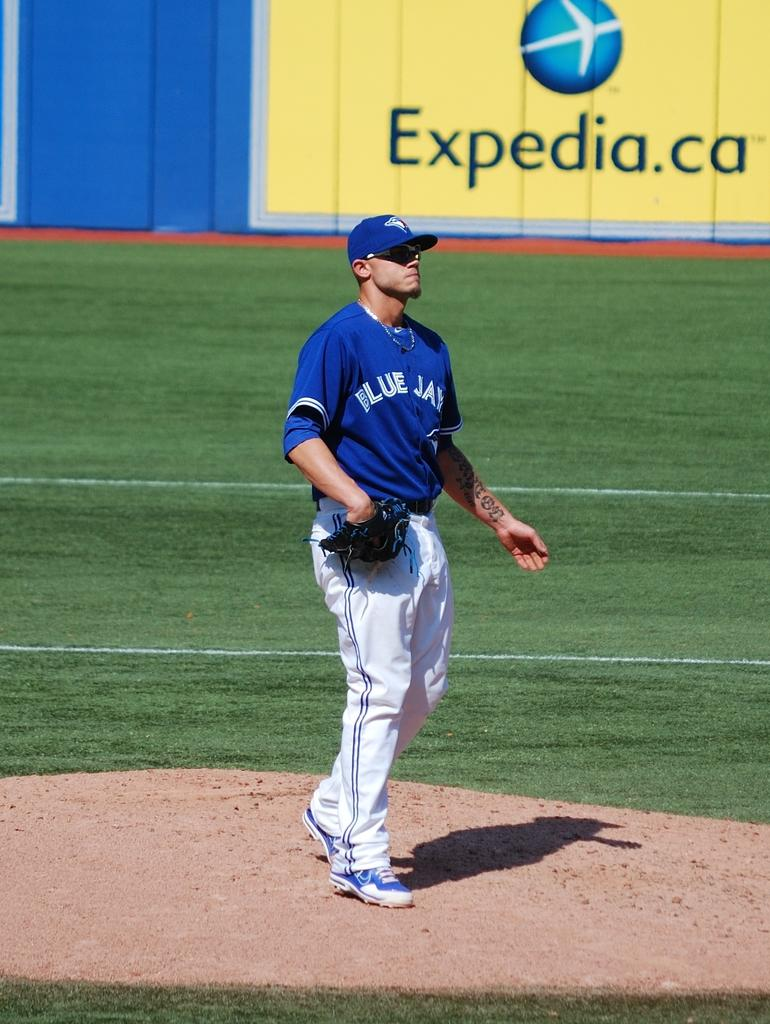<image>
Offer a succinct explanation of the picture presented. The baseball player has Blue Jays on his team uniform and Expedia.ca is advertised on the wall behind him. 